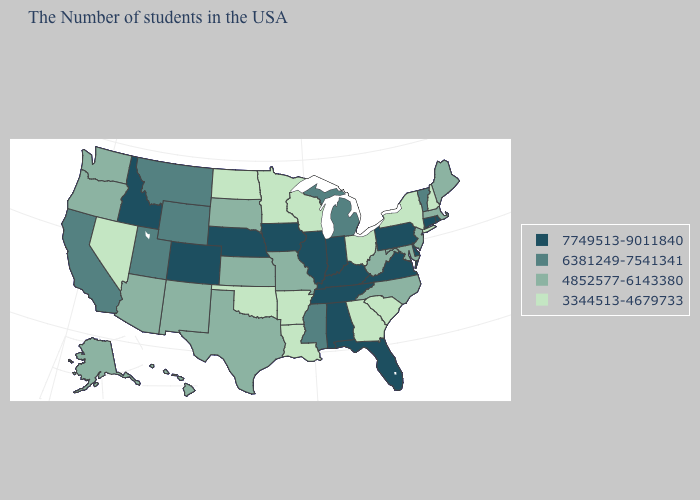Is the legend a continuous bar?
Give a very brief answer. No. Which states have the lowest value in the West?
Quick response, please. Nevada. What is the lowest value in the West?
Short answer required. 3344513-4679733. Is the legend a continuous bar?
Be succinct. No. What is the lowest value in the Northeast?
Be succinct. 3344513-4679733. Among the states that border Louisiana , which have the highest value?
Short answer required. Mississippi. Does the map have missing data?
Concise answer only. No. Which states hav the highest value in the South?
Concise answer only. Delaware, Virginia, Florida, Kentucky, Alabama, Tennessee. Does New York have the lowest value in the Northeast?
Give a very brief answer. Yes. Name the states that have a value in the range 6381249-7541341?
Be succinct. Vermont, Michigan, Mississippi, Wyoming, Utah, Montana, California. Name the states that have a value in the range 3344513-4679733?
Answer briefly. New Hampshire, New York, South Carolina, Ohio, Georgia, Wisconsin, Louisiana, Arkansas, Minnesota, Oklahoma, North Dakota, Nevada. Name the states that have a value in the range 4852577-6143380?
Give a very brief answer. Maine, Massachusetts, New Jersey, Maryland, North Carolina, West Virginia, Missouri, Kansas, Texas, South Dakota, New Mexico, Arizona, Washington, Oregon, Alaska, Hawaii. What is the value of Florida?
Concise answer only. 7749513-9011840. What is the value of Nebraska?
Short answer required. 7749513-9011840. Among the states that border Florida , does Georgia have the highest value?
Short answer required. No. 